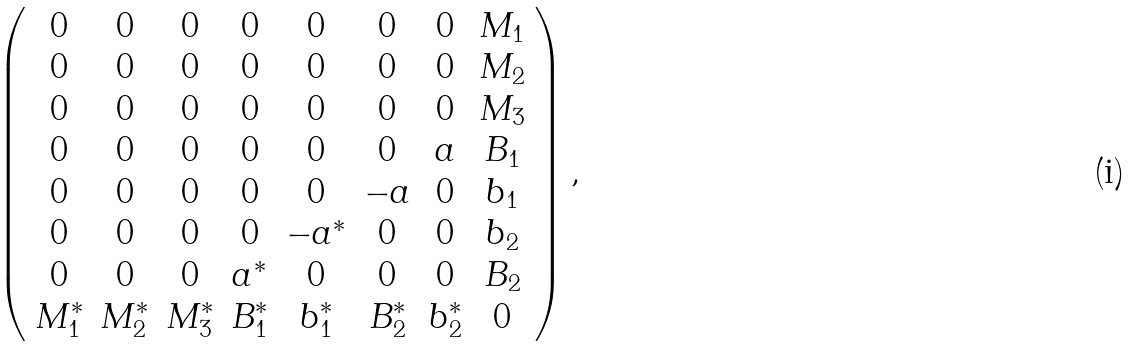<formula> <loc_0><loc_0><loc_500><loc_500>\left ( \begin{array} { c c c c c c c c } 0 & 0 & 0 & 0 & 0 & 0 & 0 & M _ { 1 } \\ 0 & 0 & 0 & 0 & 0 & 0 & 0 & M _ { 2 } \\ 0 & 0 & 0 & 0 & 0 & 0 & 0 & M _ { 3 } \\ 0 & 0 & 0 & 0 & 0 & 0 & a & B _ { 1 } \\ 0 & 0 & 0 & 0 & 0 & - a & 0 & b _ { 1 } \\ 0 & 0 & 0 & 0 & - a ^ { * } & 0 & 0 & b _ { 2 } \\ 0 & 0 & 0 & a ^ { * } & 0 & 0 & 0 & B _ { 2 } \\ M _ { 1 } ^ { * } & M _ { 2 } ^ { * } & M _ { 3 } ^ { * } & B _ { 1 } ^ { * } & b _ { 1 } ^ { * } & B _ { 2 } ^ { * } & b _ { 2 } ^ { * } & 0 \\ \end{array} \right ) ,</formula> 